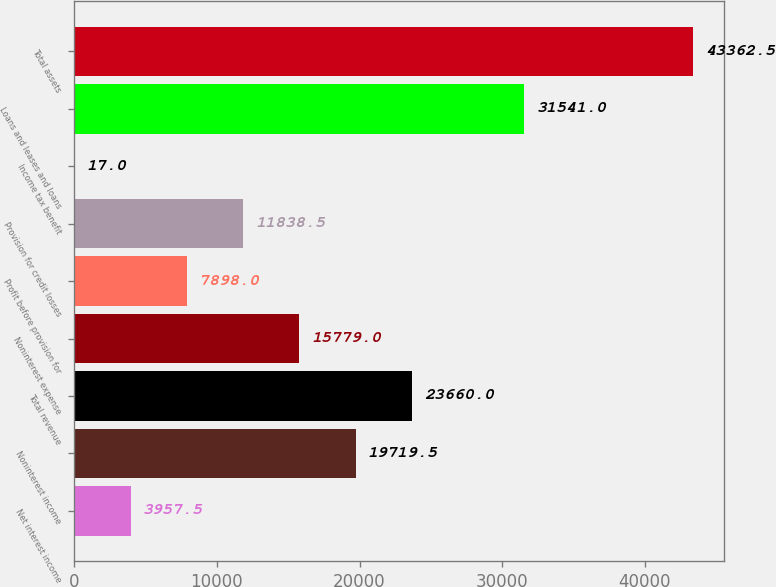<chart> <loc_0><loc_0><loc_500><loc_500><bar_chart><fcel>Net interest income<fcel>Noninterest income<fcel>Total revenue<fcel>Noninterest expense<fcel>Profit before provision for<fcel>Provision for credit losses<fcel>Income tax benefit<fcel>Loans and leases and loans<fcel>Total assets<nl><fcel>3957.5<fcel>19719.5<fcel>23660<fcel>15779<fcel>7898<fcel>11838.5<fcel>17<fcel>31541<fcel>43362.5<nl></chart> 